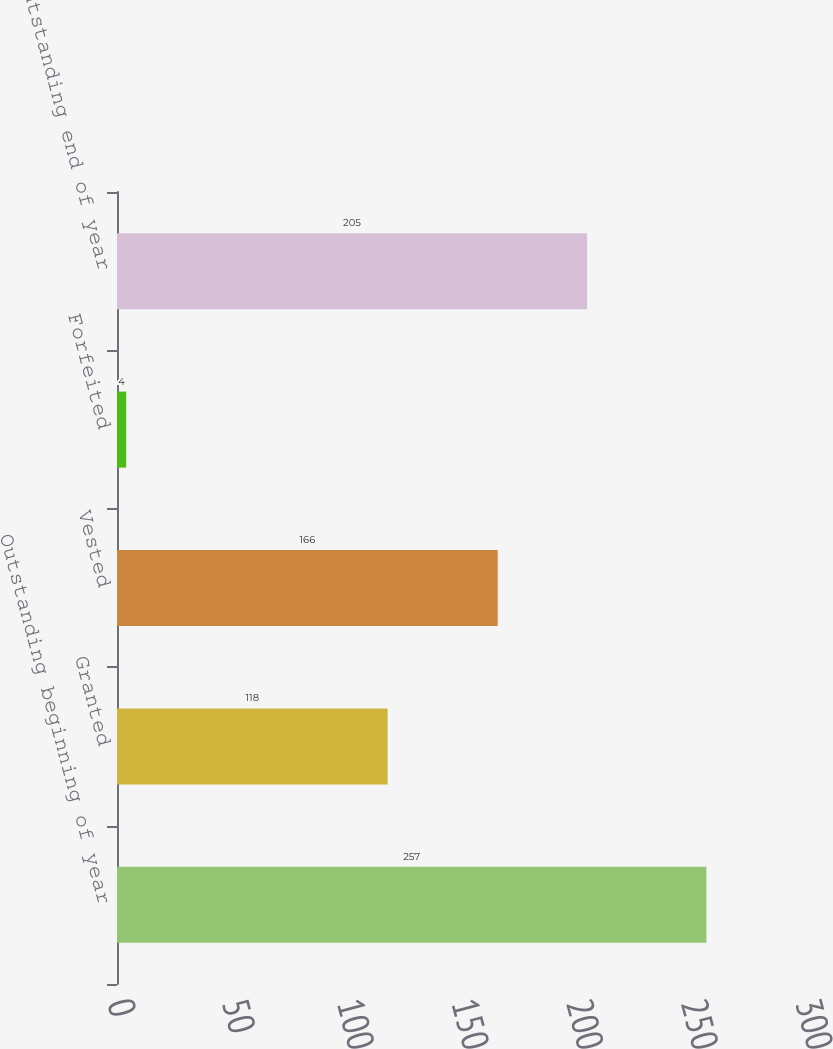<chart> <loc_0><loc_0><loc_500><loc_500><bar_chart><fcel>Outstanding beginning of year<fcel>Granted<fcel>Vested<fcel>Forfeited<fcel>Outstanding end of year<nl><fcel>257<fcel>118<fcel>166<fcel>4<fcel>205<nl></chart> 